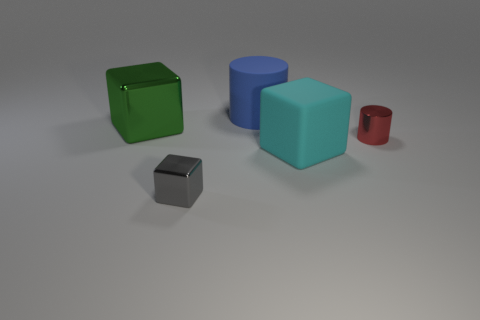Add 5 red objects. How many objects exist? 10 Subtract all blocks. How many objects are left? 2 Add 2 purple matte things. How many purple matte things exist? 2 Subtract 0 gray spheres. How many objects are left? 5 Subtract all large metallic spheres. Subtract all large cubes. How many objects are left? 3 Add 2 blue cylinders. How many blue cylinders are left? 3 